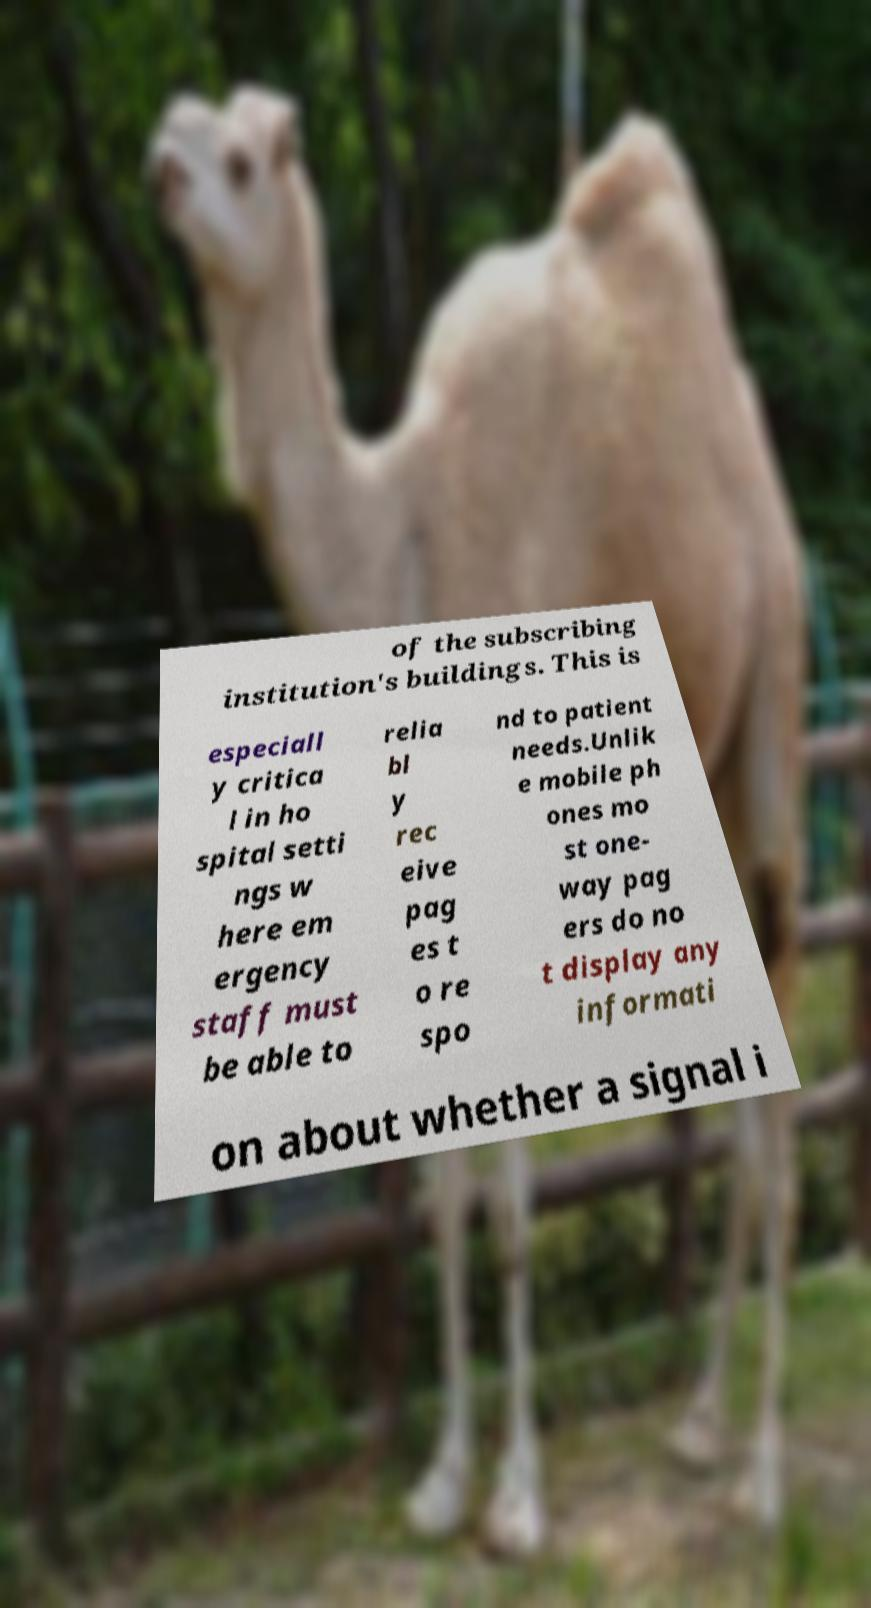Could you assist in decoding the text presented in this image and type it out clearly? of the subscribing institution's buildings. This is especiall y critica l in ho spital setti ngs w here em ergency staff must be able to relia bl y rec eive pag es t o re spo nd to patient needs.Unlik e mobile ph ones mo st one- way pag ers do no t display any informati on about whether a signal i 